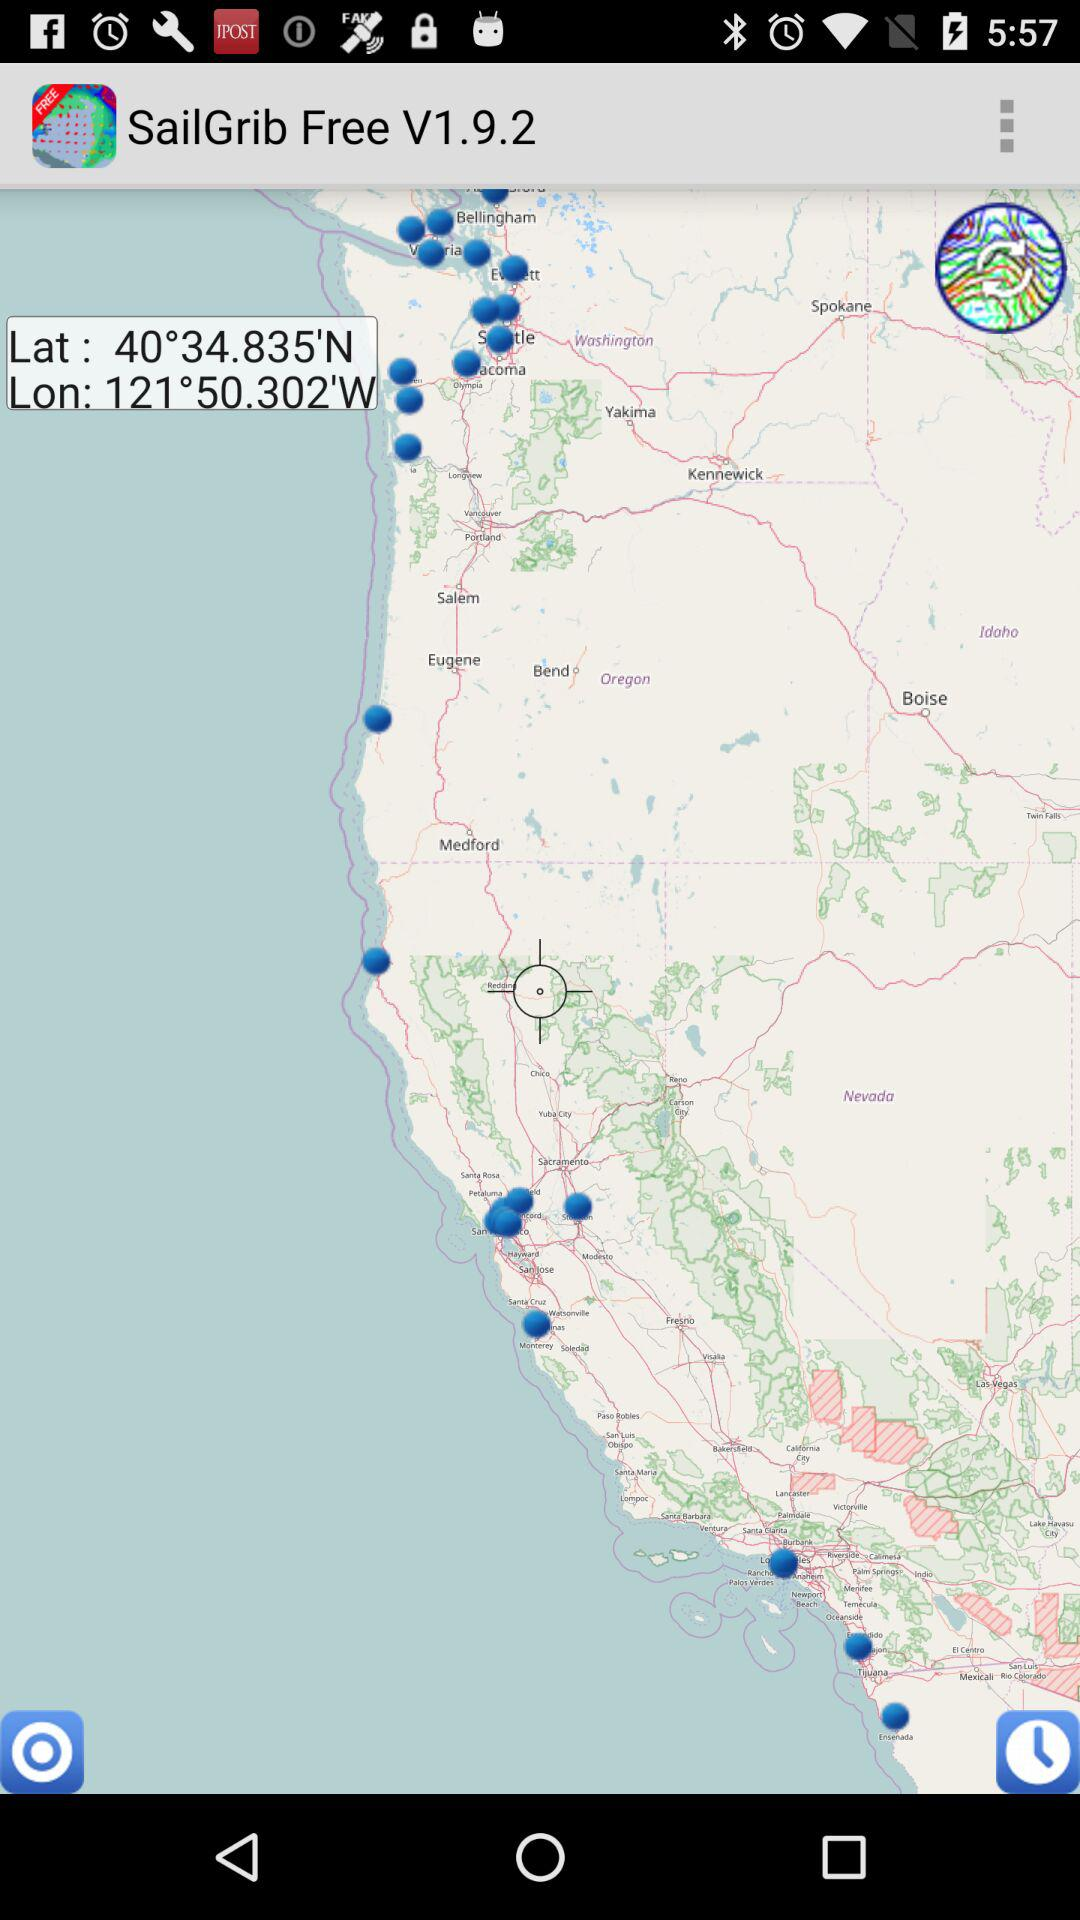What is the name of the application? The name of the application is "SailGrib". 